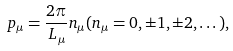<formula> <loc_0><loc_0><loc_500><loc_500>p _ { \mu } = \frac { 2 \pi } { L _ { \mu } } n _ { \mu } ( n _ { \mu } = 0 , \pm 1 , \pm 2 , \dots ) ,</formula> 